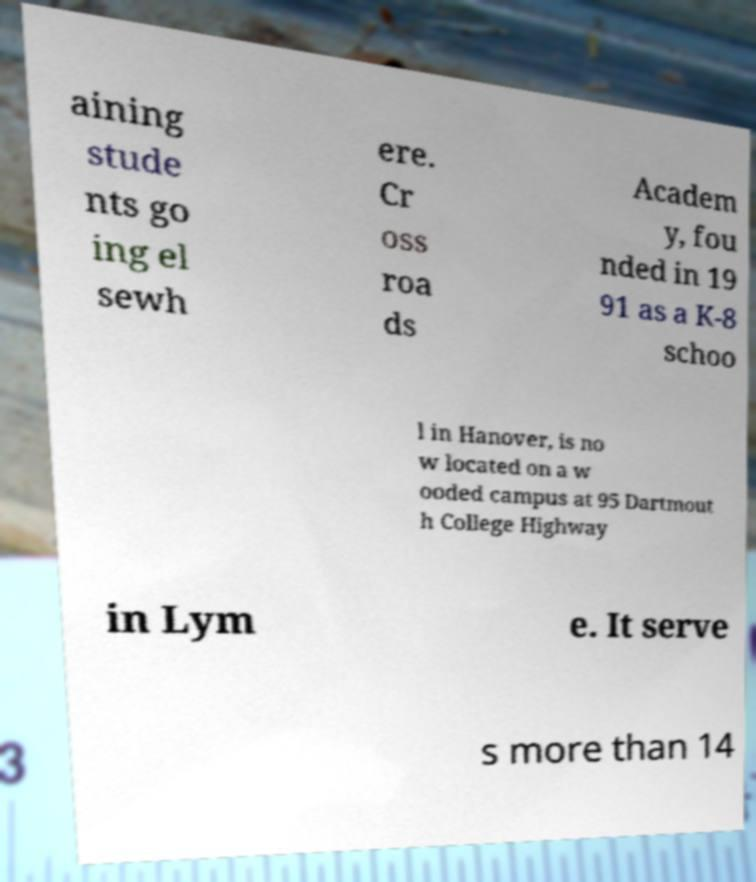Can you accurately transcribe the text from the provided image for me? aining stude nts go ing el sewh ere. Cr oss roa ds Academ y, fou nded in 19 91 as a K-8 schoo l in Hanover, is no w located on a w ooded campus at 95 Dartmout h College Highway in Lym e. It serve s more than 14 